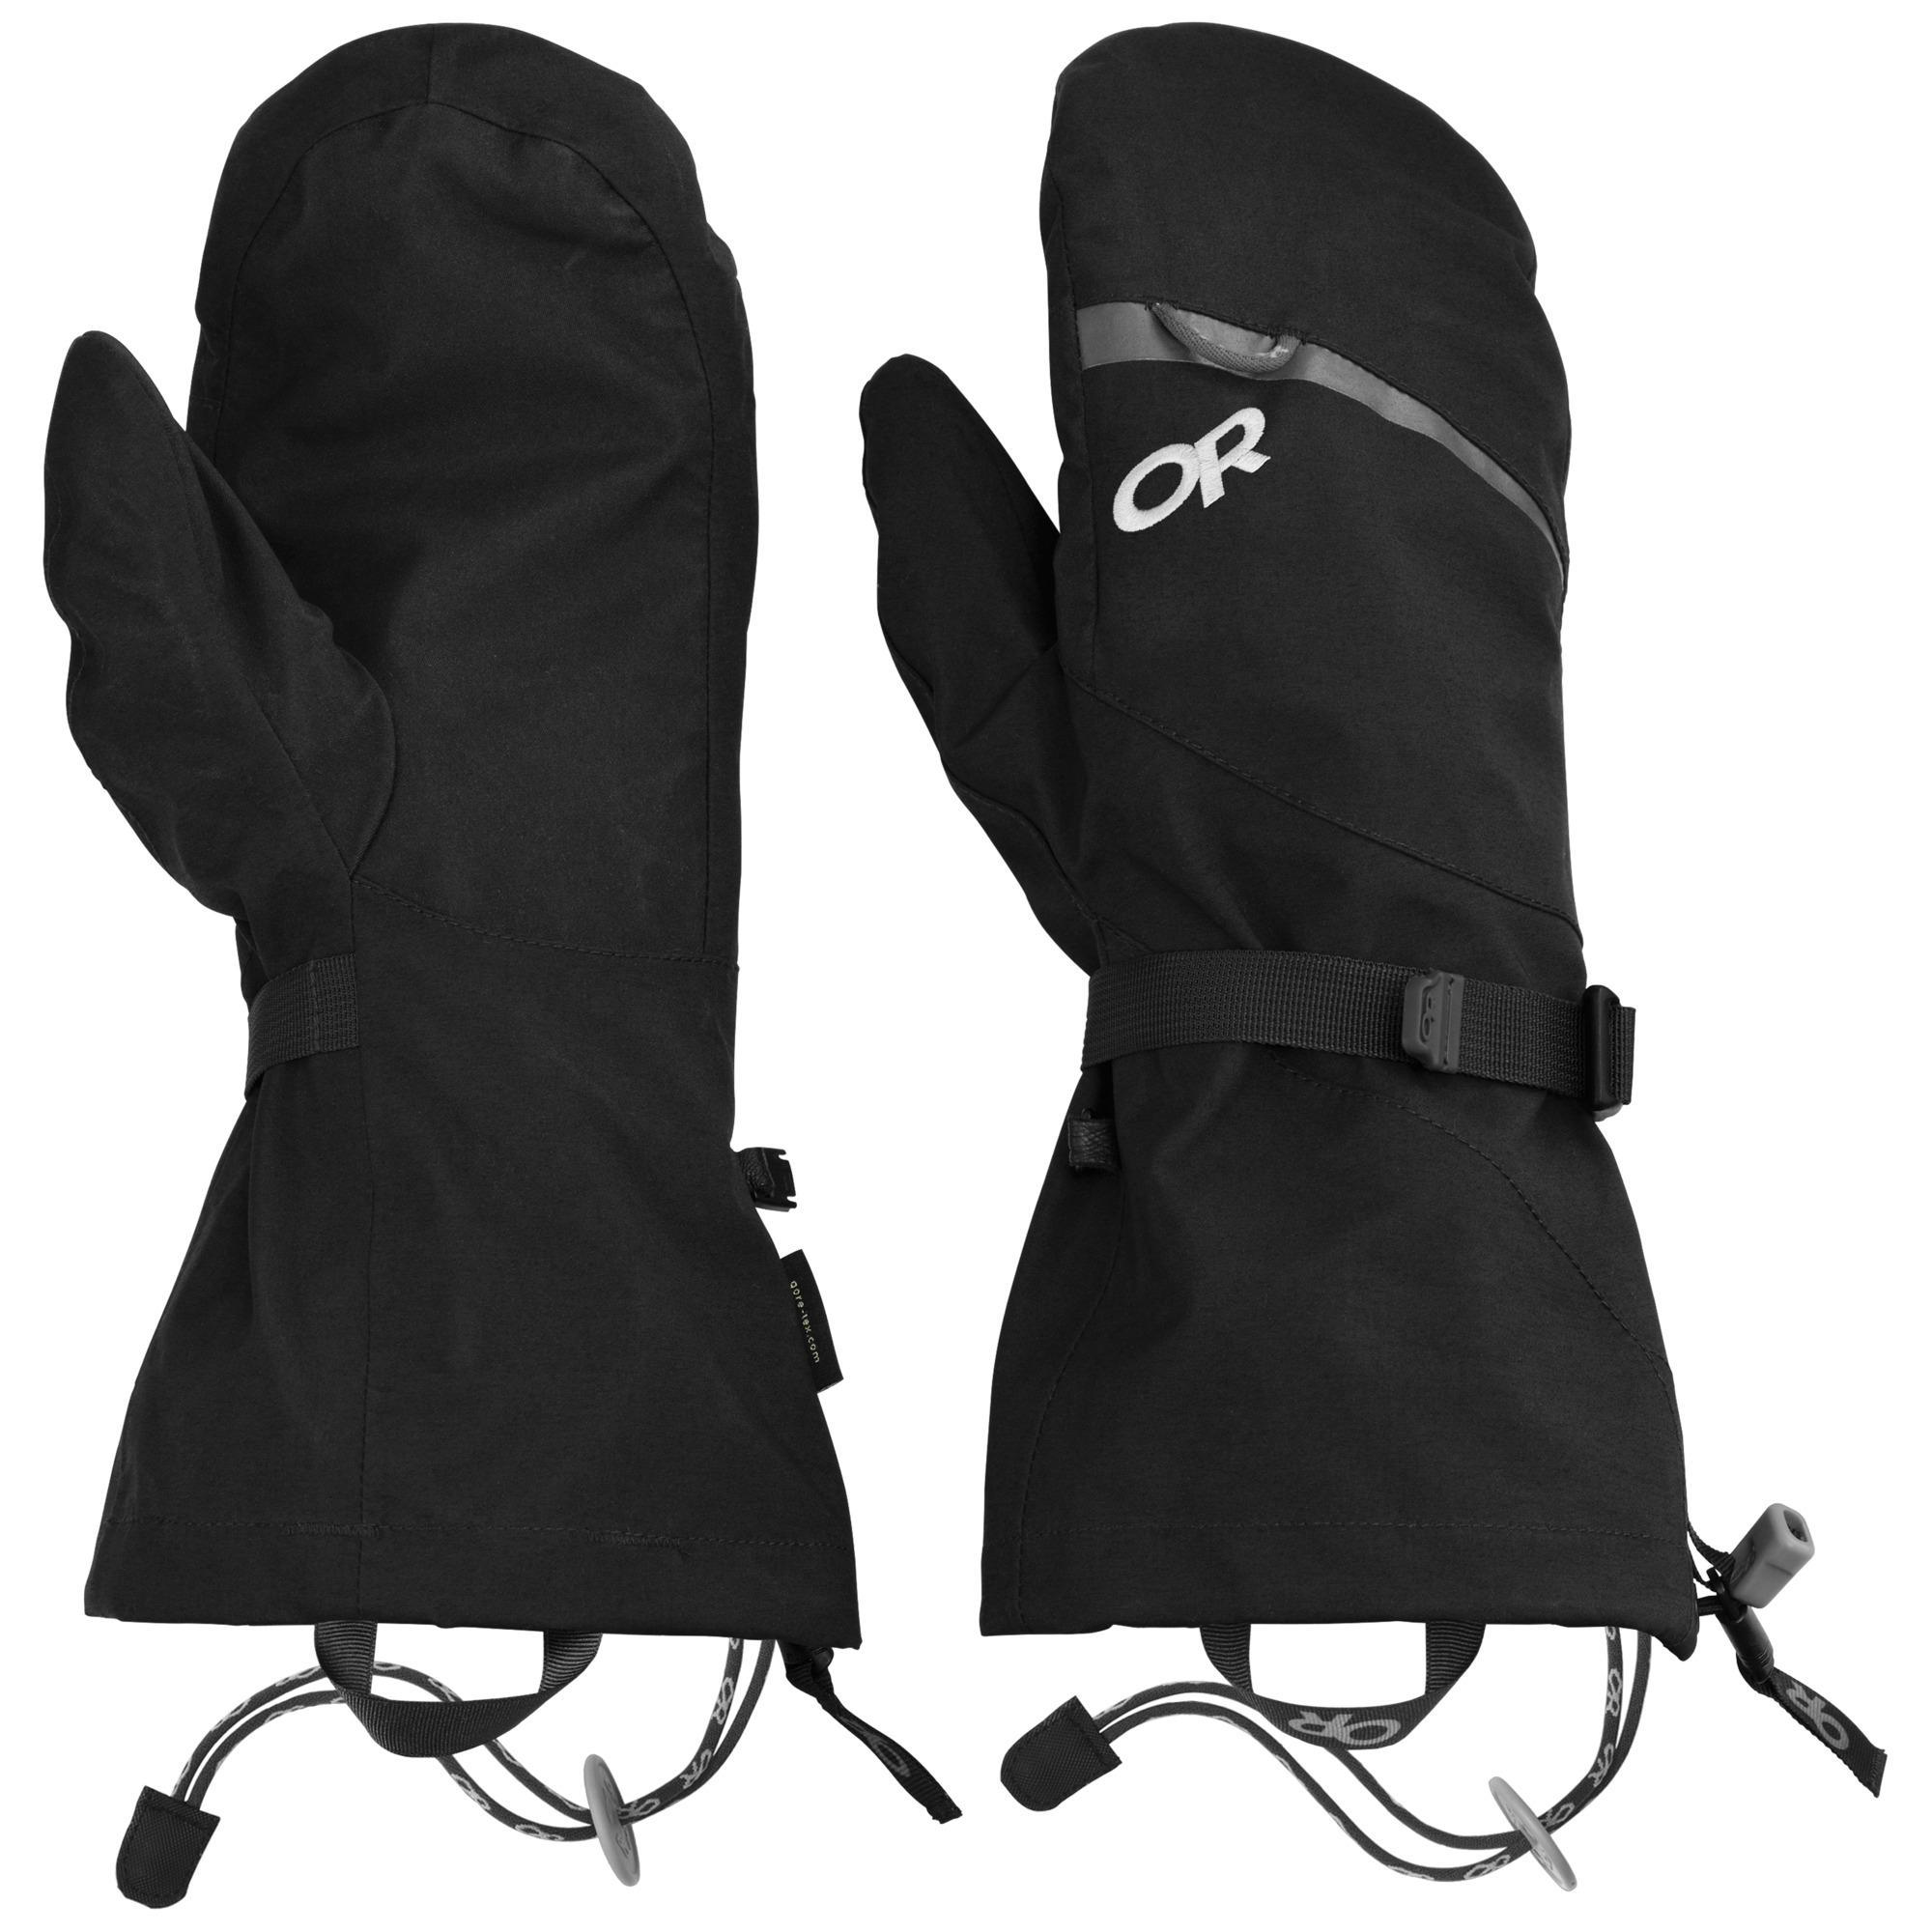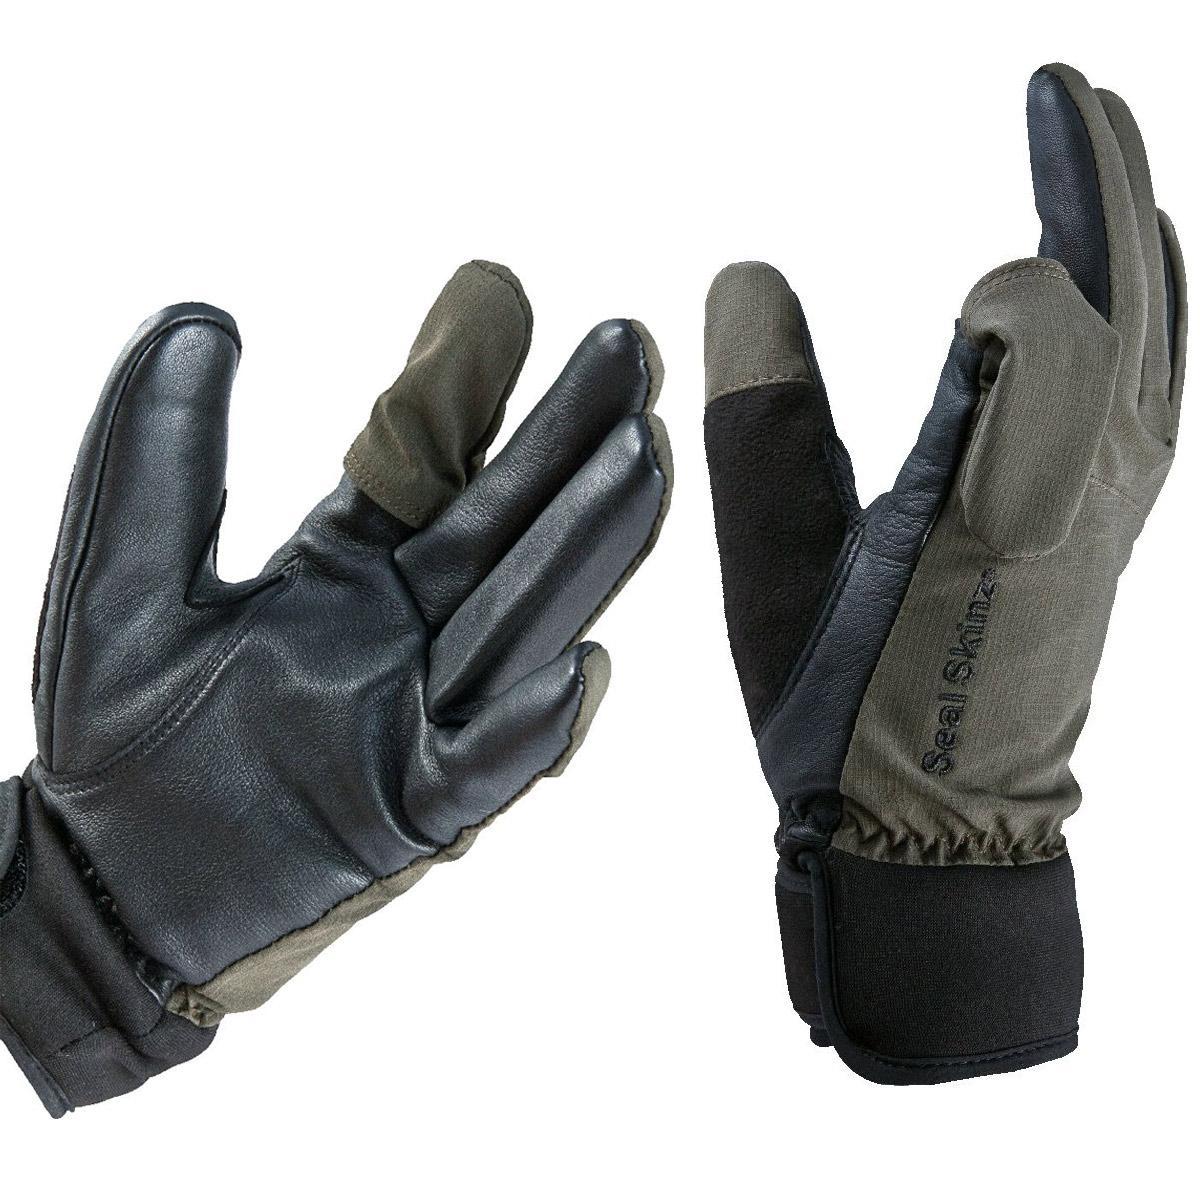The first image is the image on the left, the second image is the image on the right. Examine the images to the left and right. Is the description "There are two gloves without fingers." accurate? Answer yes or no. No. The first image is the image on the left, the second image is the image on the right. Considering the images on both sides, is "Each pair of mittens includes at least one with a rounded covered top, and no mitten has four full-length fingers with tips." valid? Answer yes or no. No. 